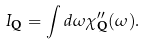Convert formula to latex. <formula><loc_0><loc_0><loc_500><loc_500>I _ { \mathbf Q } = \int d \omega \chi ^ { \prime \prime } _ { \mathbf Q } ( \omega ) .</formula> 